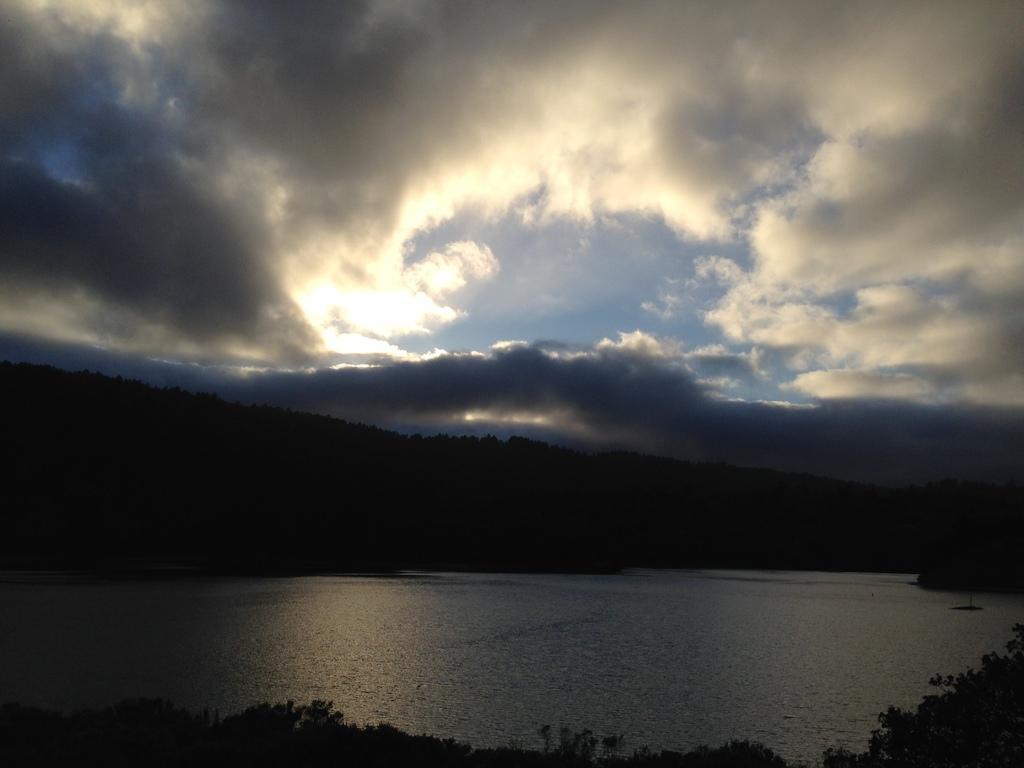Describe this image in one or two sentences. In this image there is a lake, in the background there are trees and cloudy sky. 